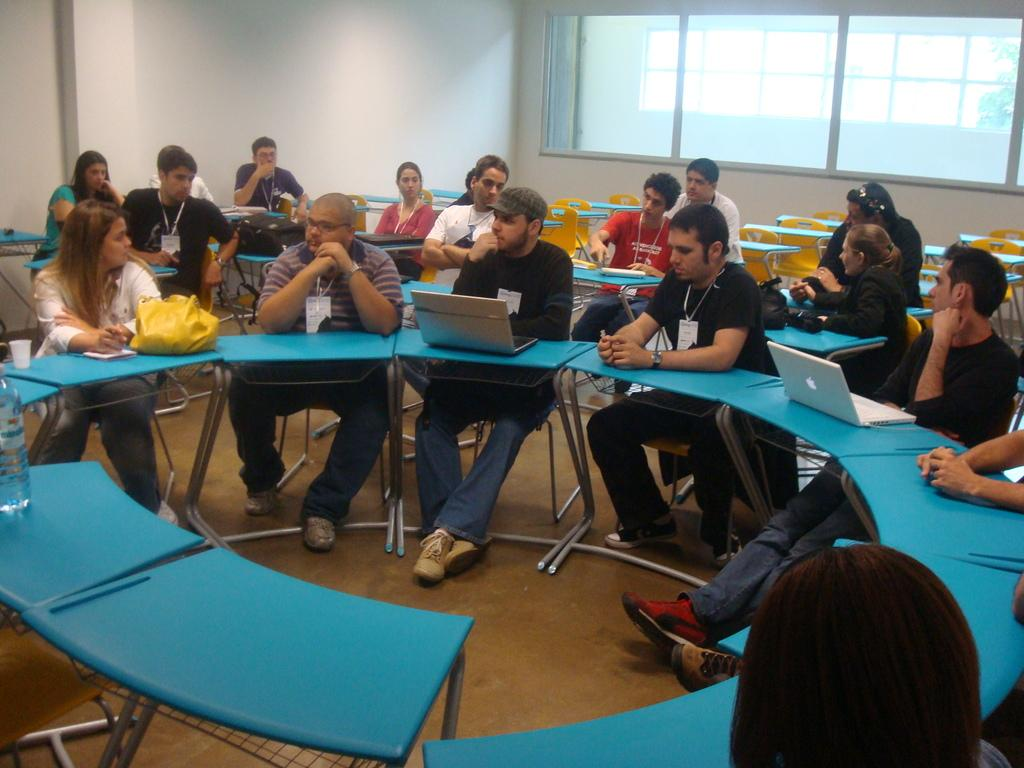Who or what is present in the image? There are people in the image. What are the people doing in the image? The people are sitting on chairs. What object can be seen on a table in front of the people? There is a laptop on a table in front of the people. What type of force is being applied to the laptop in the image? There is no indication of any force being applied to the laptop in the image; it is simply sitting on the table. 